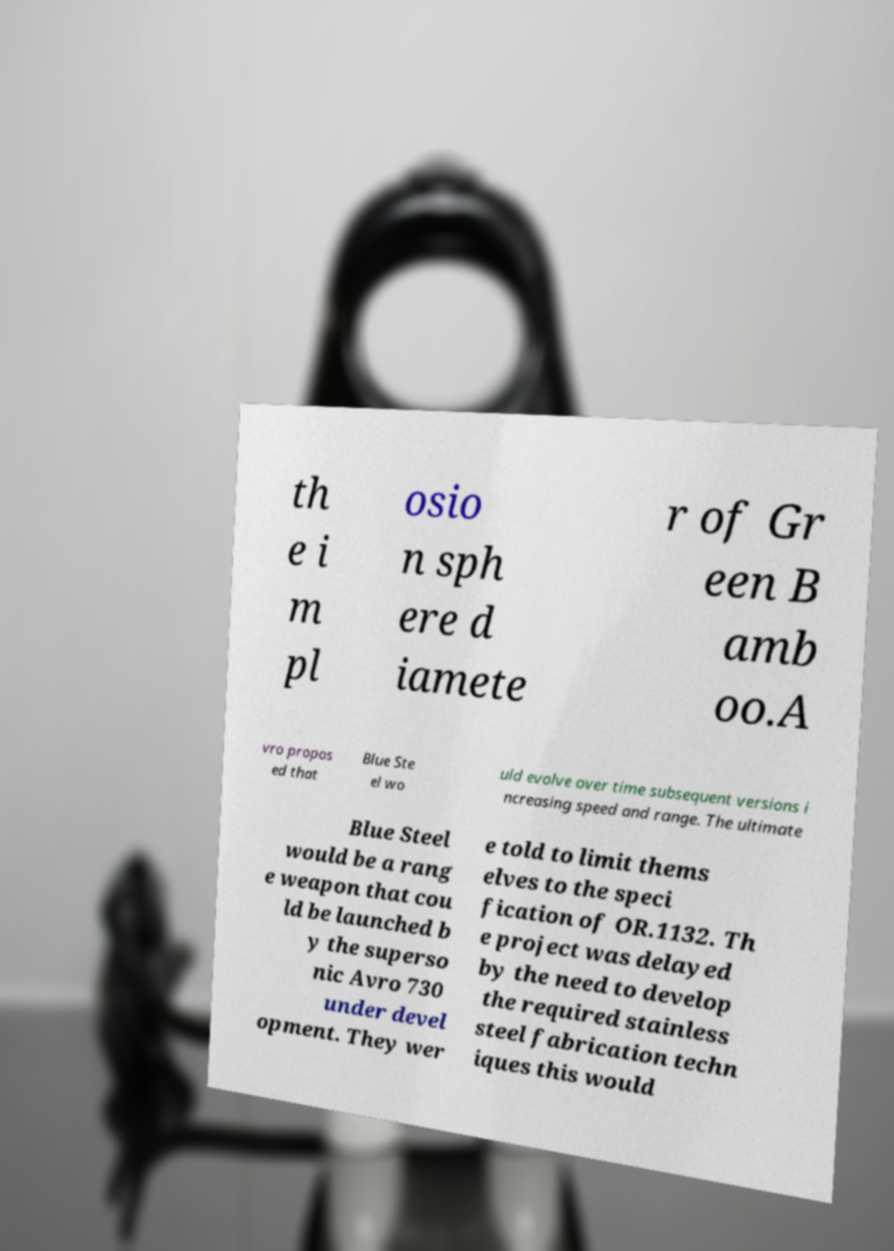Could you extract and type out the text from this image? th e i m pl osio n sph ere d iamete r of Gr een B amb oo.A vro propos ed that Blue Ste el wo uld evolve over time subsequent versions i ncreasing speed and range. The ultimate Blue Steel would be a rang e weapon that cou ld be launched b y the superso nic Avro 730 under devel opment. They wer e told to limit thems elves to the speci fication of OR.1132. Th e project was delayed by the need to develop the required stainless steel fabrication techn iques this would 